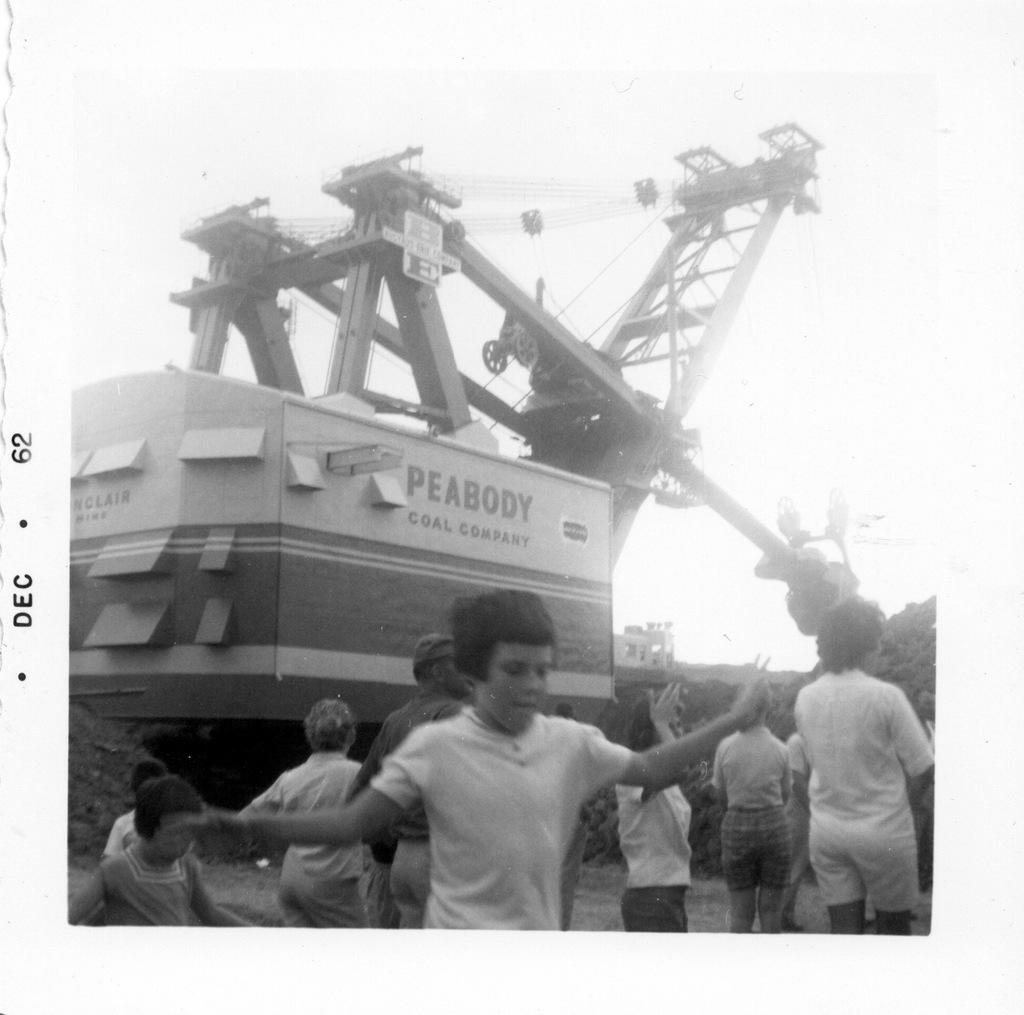What type of machinery is present in the image? There is a crane in the image. What else can be seen in the image besides the crane? There is a container in the image. Who or what is in the foreground of the image? There are kids in the foreground of the image. What is the color scheme of the image? The image is black and white. What type of lunchroom is depicted in the image? There is no lunchroom present in the image. Who is the manager of the construction site in the image? There is no manager or construction site depicted in the image; it only features a crane, a container, and kids in the foreground. 